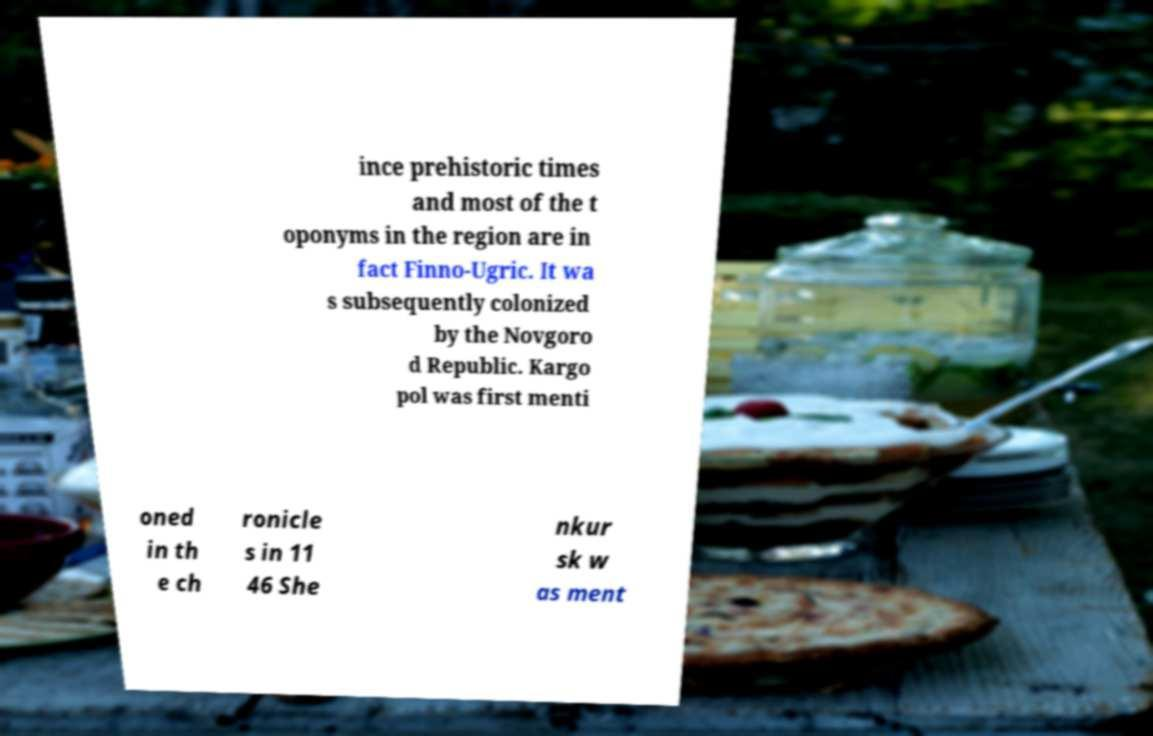Could you assist in decoding the text presented in this image and type it out clearly? ince prehistoric times and most of the t oponyms in the region are in fact Finno-Ugric. It wa s subsequently colonized by the Novgoro d Republic. Kargo pol was first menti oned in th e ch ronicle s in 11 46 She nkur sk w as ment 